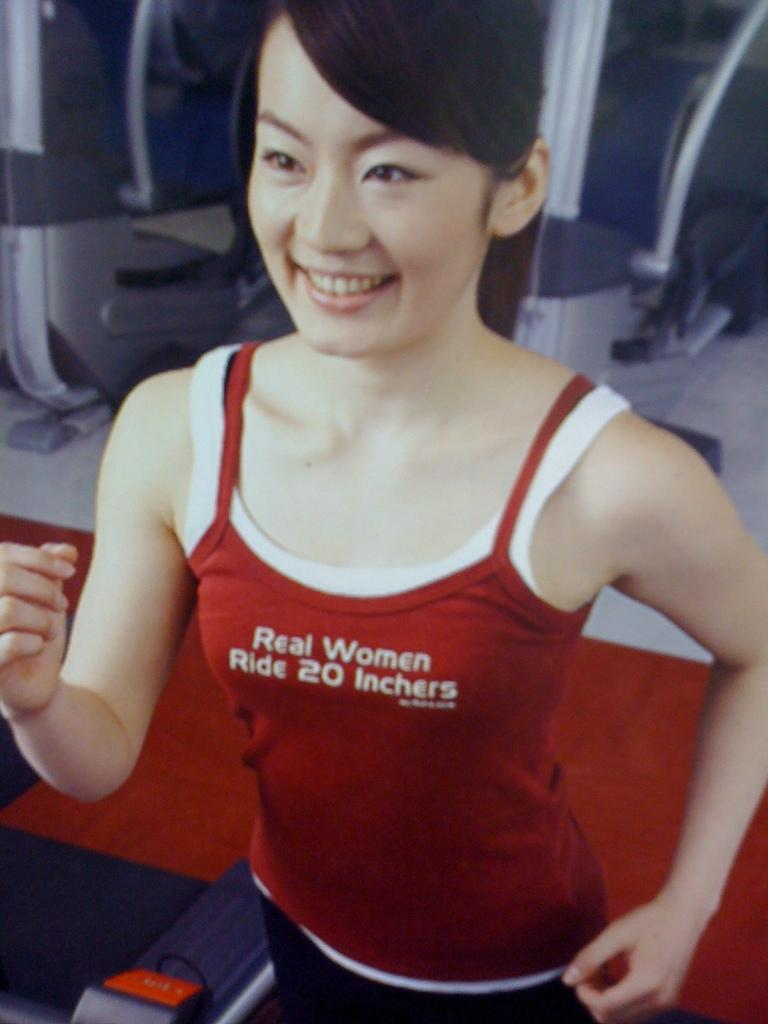Who is present in the image? There is a woman in the image. What can be seen in the background of the image? There are objects in the background of the image. What color is the carpet on the floor in the image? The carpet on the floor in the image is red. How many beads are on the cart in the image? There is no cart or beads present in the image. 